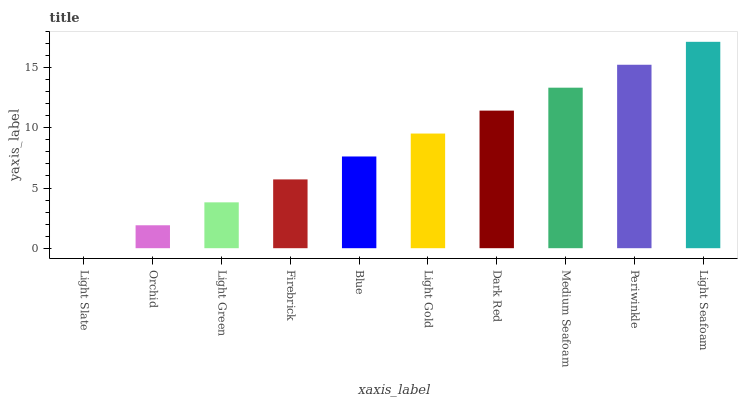Is Light Slate the minimum?
Answer yes or no. Yes. Is Light Seafoam the maximum?
Answer yes or no. Yes. Is Orchid the minimum?
Answer yes or no. No. Is Orchid the maximum?
Answer yes or no. No. Is Orchid greater than Light Slate?
Answer yes or no. Yes. Is Light Slate less than Orchid?
Answer yes or no. Yes. Is Light Slate greater than Orchid?
Answer yes or no. No. Is Orchid less than Light Slate?
Answer yes or no. No. Is Light Gold the high median?
Answer yes or no. Yes. Is Blue the low median?
Answer yes or no. Yes. Is Light Seafoam the high median?
Answer yes or no. No. Is Light Gold the low median?
Answer yes or no. No. 